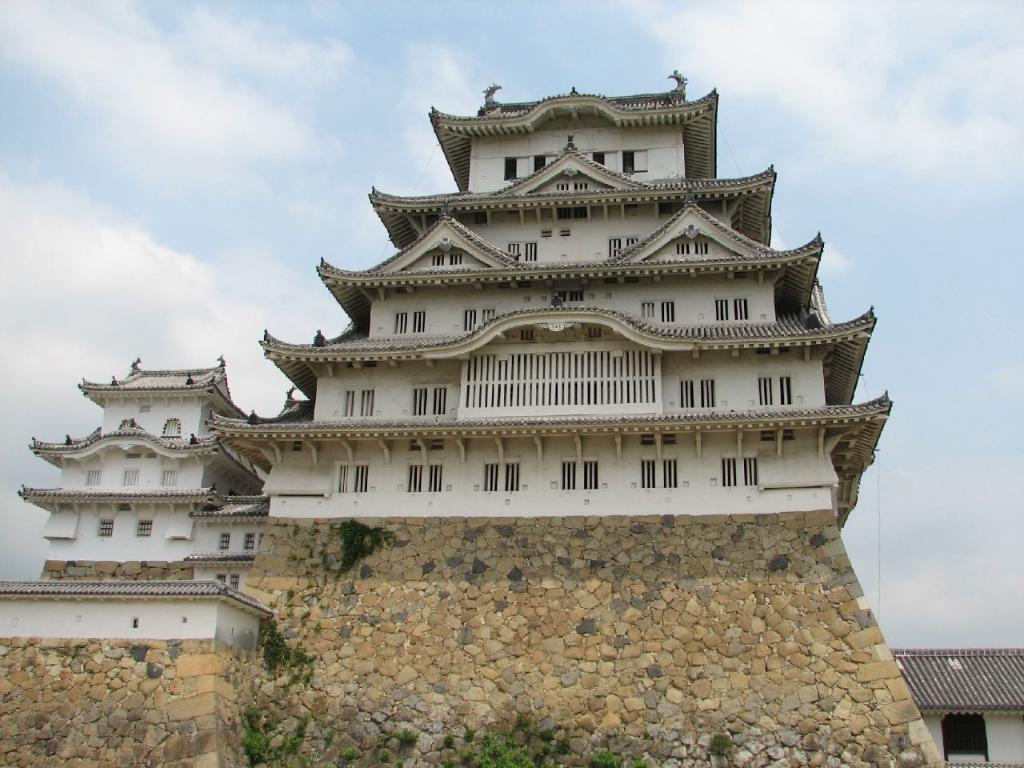What type of structures can be seen in the image? There are buildings in the image. What else is present in the image besides the buildings? There are plants in the image. What is visible in the sky at the top of the image? There are clouds in the sky at the top of the image. How many bottles can be seen floating in the water in the image? There are no bottles or water present in the image. 